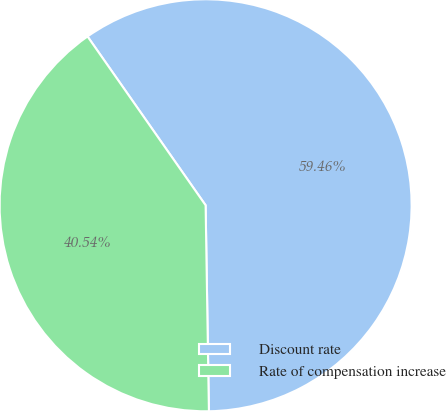Convert chart. <chart><loc_0><loc_0><loc_500><loc_500><pie_chart><fcel>Discount rate<fcel>Rate of compensation increase<nl><fcel>59.46%<fcel>40.54%<nl></chart> 